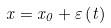Convert formula to latex. <formula><loc_0><loc_0><loc_500><loc_500>x = x _ { 0 } + \varepsilon \left ( t \right )</formula> 